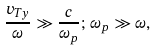Convert formula to latex. <formula><loc_0><loc_0><loc_500><loc_500>\frac { v _ { T y } } { \omega } \gg \frac { c } { \omega _ { p } } ; \, \omega _ { p } \gg \omega ,</formula> 